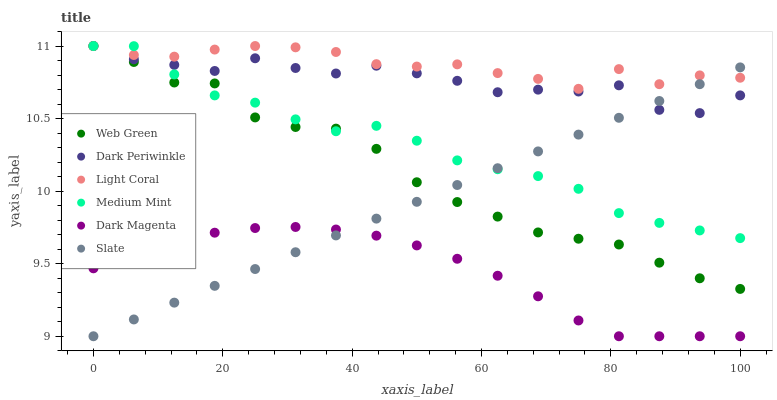Does Dark Magenta have the minimum area under the curve?
Answer yes or no. Yes. Does Light Coral have the maximum area under the curve?
Answer yes or no. Yes. Does Slate have the minimum area under the curve?
Answer yes or no. No. Does Slate have the maximum area under the curve?
Answer yes or no. No. Is Slate the smoothest?
Answer yes or no. Yes. Is Dark Periwinkle the roughest?
Answer yes or no. Yes. Is Dark Magenta the smoothest?
Answer yes or no. No. Is Dark Magenta the roughest?
Answer yes or no. No. Does Dark Magenta have the lowest value?
Answer yes or no. Yes. Does Web Green have the lowest value?
Answer yes or no. No. Does Dark Periwinkle have the highest value?
Answer yes or no. Yes. Does Slate have the highest value?
Answer yes or no. No. Is Dark Magenta less than Dark Periwinkle?
Answer yes or no. Yes. Is Dark Periwinkle greater than Dark Magenta?
Answer yes or no. Yes. Does Dark Magenta intersect Slate?
Answer yes or no. Yes. Is Dark Magenta less than Slate?
Answer yes or no. No. Is Dark Magenta greater than Slate?
Answer yes or no. No. Does Dark Magenta intersect Dark Periwinkle?
Answer yes or no. No. 